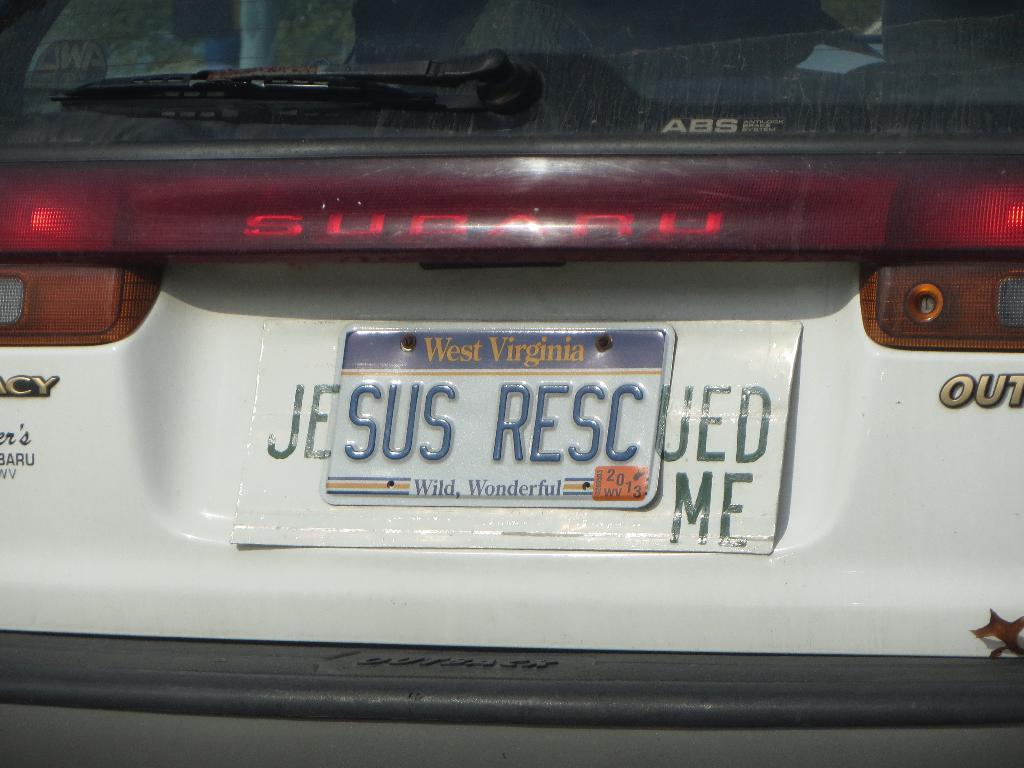What does this licence plate say?
Your answer should be very brief. Sus resc. What state is this car from?
Your response must be concise. West virginia. 